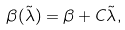Convert formula to latex. <formula><loc_0><loc_0><loc_500><loc_500>\beta ( \tilde { \lambda } ) = \beta + C \tilde { \lambda } ,</formula> 